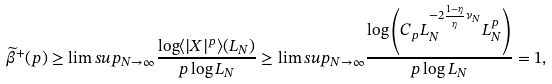Convert formula to latex. <formula><loc_0><loc_0><loc_500><loc_500>\widetilde { \beta } ^ { + } ( p ) \geq \lim s u p _ { N \to \infty } \frac { \log \langle | X | ^ { p } \rangle ( L _ { N } ) } { p \log L _ { N } } \geq \lim s u p _ { N \to \infty } \frac { \log \left ( C _ { p } L _ { N } ^ { - 2 \frac { 1 - \eta } { \eta } \nu _ { N } } L _ { N } ^ { p } \right ) } { p \log L _ { N } } = 1 ,</formula> 